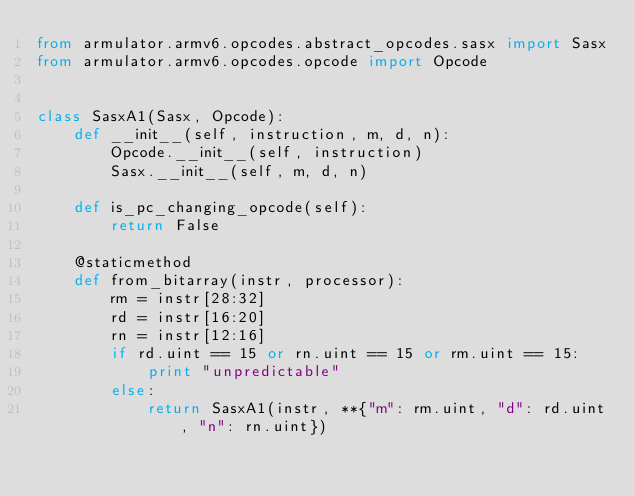Convert code to text. <code><loc_0><loc_0><loc_500><loc_500><_Python_>from armulator.armv6.opcodes.abstract_opcodes.sasx import Sasx
from armulator.armv6.opcodes.opcode import Opcode


class SasxA1(Sasx, Opcode):
    def __init__(self, instruction, m, d, n):
        Opcode.__init__(self, instruction)
        Sasx.__init__(self, m, d, n)

    def is_pc_changing_opcode(self):
        return False

    @staticmethod
    def from_bitarray(instr, processor):
        rm = instr[28:32]
        rd = instr[16:20]
        rn = instr[12:16]
        if rd.uint == 15 or rn.uint == 15 or rm.uint == 15:
            print "unpredictable"
        else:
            return SasxA1(instr, **{"m": rm.uint, "d": rd.uint, "n": rn.uint})
</code> 